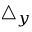<formula> <loc_0><loc_0><loc_500><loc_500>\triangle _ { y }</formula> 